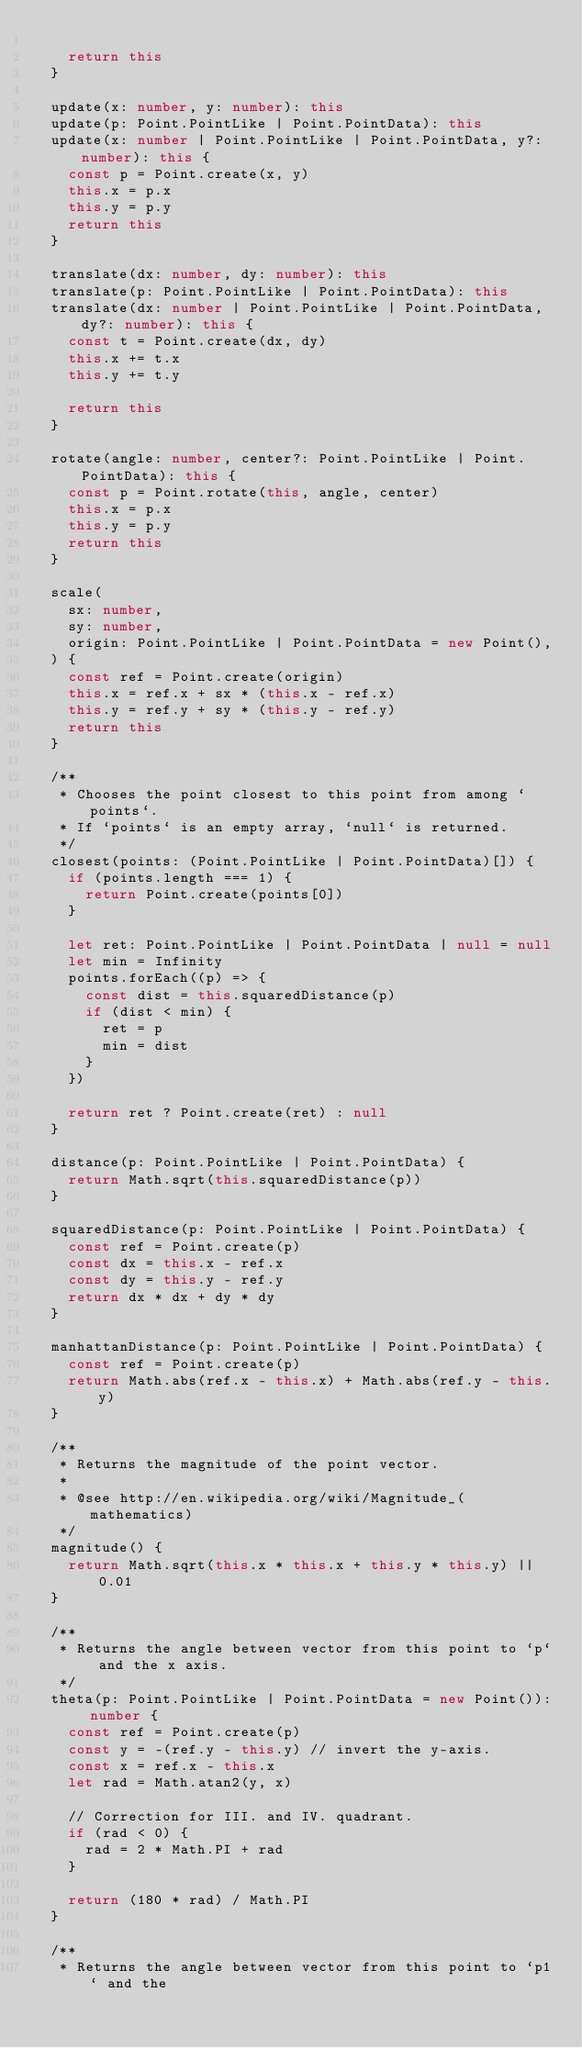Convert code to text. <code><loc_0><loc_0><loc_500><loc_500><_TypeScript_>
    return this
  }

  update(x: number, y: number): this
  update(p: Point.PointLike | Point.PointData): this
  update(x: number | Point.PointLike | Point.PointData, y?: number): this {
    const p = Point.create(x, y)
    this.x = p.x
    this.y = p.y
    return this
  }

  translate(dx: number, dy: number): this
  translate(p: Point.PointLike | Point.PointData): this
  translate(dx: number | Point.PointLike | Point.PointData, dy?: number): this {
    const t = Point.create(dx, dy)
    this.x += t.x
    this.y += t.y

    return this
  }

  rotate(angle: number, center?: Point.PointLike | Point.PointData): this {
    const p = Point.rotate(this, angle, center)
    this.x = p.x
    this.y = p.y
    return this
  }

  scale(
    sx: number,
    sy: number,
    origin: Point.PointLike | Point.PointData = new Point(),
  ) {
    const ref = Point.create(origin)
    this.x = ref.x + sx * (this.x - ref.x)
    this.y = ref.y + sy * (this.y - ref.y)
    return this
  }

  /**
   * Chooses the point closest to this point from among `points`.
   * If `points` is an empty array, `null` is returned.
   */
  closest(points: (Point.PointLike | Point.PointData)[]) {
    if (points.length === 1) {
      return Point.create(points[0])
    }

    let ret: Point.PointLike | Point.PointData | null = null
    let min = Infinity
    points.forEach((p) => {
      const dist = this.squaredDistance(p)
      if (dist < min) {
        ret = p
        min = dist
      }
    })

    return ret ? Point.create(ret) : null
  }

  distance(p: Point.PointLike | Point.PointData) {
    return Math.sqrt(this.squaredDistance(p))
  }

  squaredDistance(p: Point.PointLike | Point.PointData) {
    const ref = Point.create(p)
    const dx = this.x - ref.x
    const dy = this.y - ref.y
    return dx * dx + dy * dy
  }

  manhattanDistance(p: Point.PointLike | Point.PointData) {
    const ref = Point.create(p)
    return Math.abs(ref.x - this.x) + Math.abs(ref.y - this.y)
  }

  /**
   * Returns the magnitude of the point vector.
   *
   * @see http://en.wikipedia.org/wiki/Magnitude_(mathematics)
   */
  magnitude() {
    return Math.sqrt(this.x * this.x + this.y * this.y) || 0.01
  }

  /**
   * Returns the angle between vector from this point to `p` and the x axis.
   */
  theta(p: Point.PointLike | Point.PointData = new Point()): number {
    const ref = Point.create(p)
    const y = -(ref.y - this.y) // invert the y-axis.
    const x = ref.x - this.x
    let rad = Math.atan2(y, x)

    // Correction for III. and IV. quadrant.
    if (rad < 0) {
      rad = 2 * Math.PI + rad
    }

    return (180 * rad) / Math.PI
  }

  /**
   * Returns the angle between vector from this point to `p1` and the</code> 